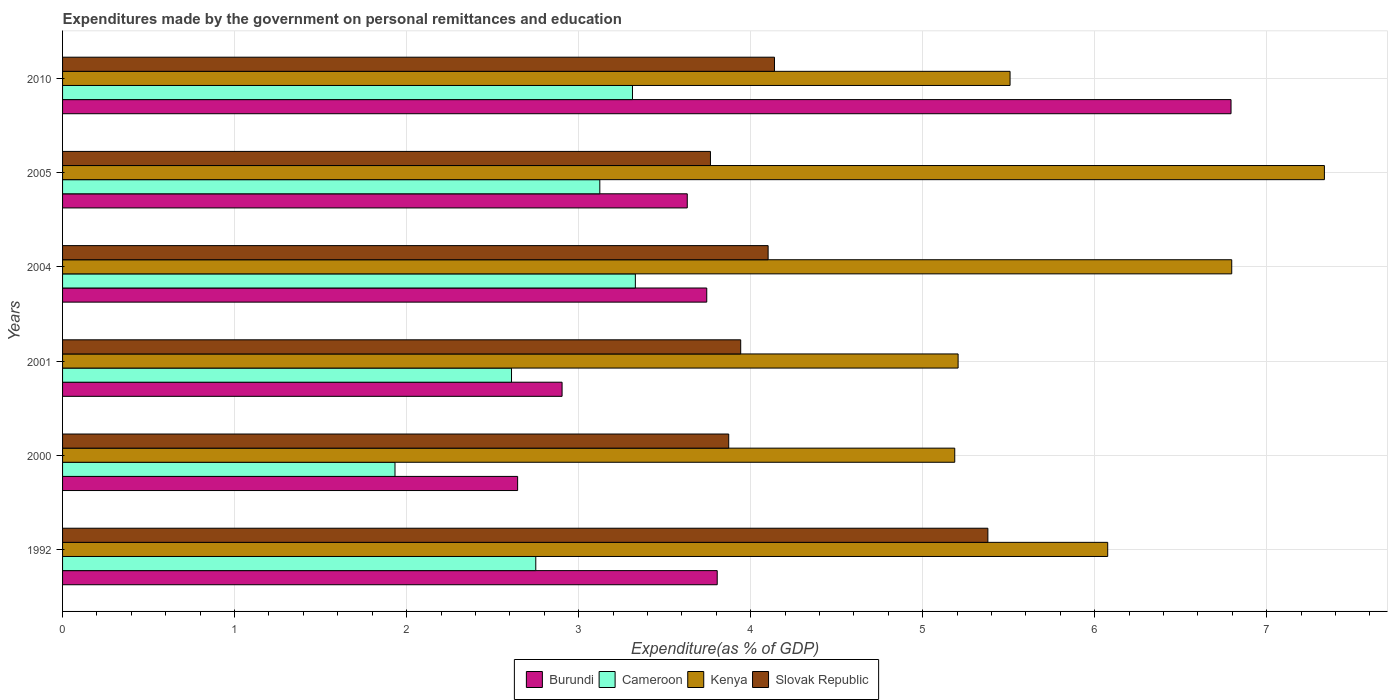Are the number of bars on each tick of the Y-axis equal?
Your answer should be very brief. Yes. How many bars are there on the 1st tick from the top?
Provide a short and direct response. 4. In how many cases, is the number of bars for a given year not equal to the number of legend labels?
Ensure brevity in your answer.  0. What is the expenditures made by the government on personal remittances and education in Cameroon in 2000?
Your answer should be compact. 1.93. Across all years, what is the maximum expenditures made by the government on personal remittances and education in Kenya?
Ensure brevity in your answer.  7.34. Across all years, what is the minimum expenditures made by the government on personal remittances and education in Slovak Republic?
Make the answer very short. 3.77. In which year was the expenditures made by the government on personal remittances and education in Kenya maximum?
Provide a succinct answer. 2005. In which year was the expenditures made by the government on personal remittances and education in Burundi minimum?
Ensure brevity in your answer.  2000. What is the total expenditures made by the government on personal remittances and education in Kenya in the graph?
Keep it short and to the point. 36.11. What is the difference between the expenditures made by the government on personal remittances and education in Cameroon in 2001 and that in 2005?
Provide a short and direct response. -0.51. What is the difference between the expenditures made by the government on personal remittances and education in Kenya in 1992 and the expenditures made by the government on personal remittances and education in Slovak Republic in 2001?
Make the answer very short. 2.13. What is the average expenditures made by the government on personal remittances and education in Slovak Republic per year?
Give a very brief answer. 4.2. In the year 2005, what is the difference between the expenditures made by the government on personal remittances and education in Burundi and expenditures made by the government on personal remittances and education in Cameroon?
Your response must be concise. 0.51. What is the ratio of the expenditures made by the government on personal remittances and education in Burundi in 2004 to that in 2010?
Provide a short and direct response. 0.55. What is the difference between the highest and the second highest expenditures made by the government on personal remittances and education in Kenya?
Keep it short and to the point. 0.54. What is the difference between the highest and the lowest expenditures made by the government on personal remittances and education in Kenya?
Offer a terse response. 2.15. In how many years, is the expenditures made by the government on personal remittances and education in Cameroon greater than the average expenditures made by the government on personal remittances and education in Cameroon taken over all years?
Keep it short and to the point. 3. What does the 2nd bar from the top in 2004 represents?
Give a very brief answer. Kenya. What does the 3rd bar from the bottom in 2001 represents?
Provide a succinct answer. Kenya. How many bars are there?
Your answer should be compact. 24. What is the difference between two consecutive major ticks on the X-axis?
Give a very brief answer. 1. Where does the legend appear in the graph?
Your response must be concise. Bottom center. How many legend labels are there?
Make the answer very short. 4. What is the title of the graph?
Keep it short and to the point. Expenditures made by the government on personal remittances and education. What is the label or title of the X-axis?
Provide a succinct answer. Expenditure(as % of GDP). What is the label or title of the Y-axis?
Keep it short and to the point. Years. What is the Expenditure(as % of GDP) of Burundi in 1992?
Keep it short and to the point. 3.81. What is the Expenditure(as % of GDP) in Cameroon in 1992?
Offer a very short reply. 2.75. What is the Expenditure(as % of GDP) of Kenya in 1992?
Your answer should be compact. 6.08. What is the Expenditure(as % of GDP) in Slovak Republic in 1992?
Your answer should be very brief. 5.38. What is the Expenditure(as % of GDP) in Burundi in 2000?
Provide a short and direct response. 2.65. What is the Expenditure(as % of GDP) in Cameroon in 2000?
Offer a very short reply. 1.93. What is the Expenditure(as % of GDP) in Kenya in 2000?
Your answer should be very brief. 5.19. What is the Expenditure(as % of GDP) of Slovak Republic in 2000?
Keep it short and to the point. 3.87. What is the Expenditure(as % of GDP) in Burundi in 2001?
Keep it short and to the point. 2.9. What is the Expenditure(as % of GDP) in Cameroon in 2001?
Your answer should be compact. 2.61. What is the Expenditure(as % of GDP) of Kenya in 2001?
Offer a terse response. 5.21. What is the Expenditure(as % of GDP) in Slovak Republic in 2001?
Provide a short and direct response. 3.94. What is the Expenditure(as % of GDP) of Burundi in 2004?
Your answer should be very brief. 3.74. What is the Expenditure(as % of GDP) of Cameroon in 2004?
Provide a succinct answer. 3.33. What is the Expenditure(as % of GDP) of Kenya in 2004?
Make the answer very short. 6.8. What is the Expenditure(as % of GDP) of Slovak Republic in 2004?
Ensure brevity in your answer.  4.1. What is the Expenditure(as % of GDP) in Burundi in 2005?
Make the answer very short. 3.63. What is the Expenditure(as % of GDP) of Cameroon in 2005?
Your answer should be very brief. 3.12. What is the Expenditure(as % of GDP) of Kenya in 2005?
Provide a succinct answer. 7.34. What is the Expenditure(as % of GDP) of Slovak Republic in 2005?
Provide a short and direct response. 3.77. What is the Expenditure(as % of GDP) in Burundi in 2010?
Keep it short and to the point. 6.79. What is the Expenditure(as % of GDP) of Cameroon in 2010?
Offer a terse response. 3.31. What is the Expenditure(as % of GDP) in Kenya in 2010?
Offer a terse response. 5.51. What is the Expenditure(as % of GDP) of Slovak Republic in 2010?
Provide a short and direct response. 4.14. Across all years, what is the maximum Expenditure(as % of GDP) of Burundi?
Provide a short and direct response. 6.79. Across all years, what is the maximum Expenditure(as % of GDP) in Cameroon?
Provide a succinct answer. 3.33. Across all years, what is the maximum Expenditure(as % of GDP) of Kenya?
Ensure brevity in your answer.  7.34. Across all years, what is the maximum Expenditure(as % of GDP) in Slovak Republic?
Offer a terse response. 5.38. Across all years, what is the minimum Expenditure(as % of GDP) of Burundi?
Your response must be concise. 2.65. Across all years, what is the minimum Expenditure(as % of GDP) in Cameroon?
Provide a short and direct response. 1.93. Across all years, what is the minimum Expenditure(as % of GDP) in Kenya?
Make the answer very short. 5.19. Across all years, what is the minimum Expenditure(as % of GDP) of Slovak Republic?
Offer a very short reply. 3.77. What is the total Expenditure(as % of GDP) in Burundi in the graph?
Make the answer very short. 23.52. What is the total Expenditure(as % of GDP) in Cameroon in the graph?
Offer a terse response. 17.06. What is the total Expenditure(as % of GDP) in Kenya in the graph?
Your answer should be compact. 36.11. What is the total Expenditure(as % of GDP) in Slovak Republic in the graph?
Offer a very short reply. 25.2. What is the difference between the Expenditure(as % of GDP) in Burundi in 1992 and that in 2000?
Offer a terse response. 1.16. What is the difference between the Expenditure(as % of GDP) in Cameroon in 1992 and that in 2000?
Your response must be concise. 0.82. What is the difference between the Expenditure(as % of GDP) of Kenya in 1992 and that in 2000?
Keep it short and to the point. 0.89. What is the difference between the Expenditure(as % of GDP) of Slovak Republic in 1992 and that in 2000?
Provide a short and direct response. 1.51. What is the difference between the Expenditure(as % of GDP) in Burundi in 1992 and that in 2001?
Ensure brevity in your answer.  0.9. What is the difference between the Expenditure(as % of GDP) in Cameroon in 1992 and that in 2001?
Make the answer very short. 0.14. What is the difference between the Expenditure(as % of GDP) of Kenya in 1992 and that in 2001?
Your response must be concise. 0.87. What is the difference between the Expenditure(as % of GDP) of Slovak Republic in 1992 and that in 2001?
Keep it short and to the point. 1.44. What is the difference between the Expenditure(as % of GDP) in Burundi in 1992 and that in 2004?
Keep it short and to the point. 0.06. What is the difference between the Expenditure(as % of GDP) in Cameroon in 1992 and that in 2004?
Your answer should be compact. -0.58. What is the difference between the Expenditure(as % of GDP) of Kenya in 1992 and that in 2004?
Ensure brevity in your answer.  -0.72. What is the difference between the Expenditure(as % of GDP) of Slovak Republic in 1992 and that in 2004?
Ensure brevity in your answer.  1.28. What is the difference between the Expenditure(as % of GDP) of Burundi in 1992 and that in 2005?
Give a very brief answer. 0.17. What is the difference between the Expenditure(as % of GDP) in Cameroon in 1992 and that in 2005?
Your answer should be very brief. -0.37. What is the difference between the Expenditure(as % of GDP) of Kenya in 1992 and that in 2005?
Offer a very short reply. -1.26. What is the difference between the Expenditure(as % of GDP) of Slovak Republic in 1992 and that in 2005?
Your response must be concise. 1.61. What is the difference between the Expenditure(as % of GDP) of Burundi in 1992 and that in 2010?
Your response must be concise. -2.99. What is the difference between the Expenditure(as % of GDP) in Cameroon in 1992 and that in 2010?
Provide a short and direct response. -0.56. What is the difference between the Expenditure(as % of GDP) of Kenya in 1992 and that in 2010?
Your answer should be compact. 0.57. What is the difference between the Expenditure(as % of GDP) in Slovak Republic in 1992 and that in 2010?
Your answer should be very brief. 1.24. What is the difference between the Expenditure(as % of GDP) in Burundi in 2000 and that in 2001?
Your response must be concise. -0.26. What is the difference between the Expenditure(as % of GDP) in Cameroon in 2000 and that in 2001?
Offer a very short reply. -0.68. What is the difference between the Expenditure(as % of GDP) in Kenya in 2000 and that in 2001?
Give a very brief answer. -0.02. What is the difference between the Expenditure(as % of GDP) of Slovak Republic in 2000 and that in 2001?
Make the answer very short. -0.07. What is the difference between the Expenditure(as % of GDP) of Burundi in 2000 and that in 2004?
Provide a short and direct response. -1.1. What is the difference between the Expenditure(as % of GDP) in Cameroon in 2000 and that in 2004?
Ensure brevity in your answer.  -1.4. What is the difference between the Expenditure(as % of GDP) of Kenya in 2000 and that in 2004?
Make the answer very short. -1.61. What is the difference between the Expenditure(as % of GDP) of Slovak Republic in 2000 and that in 2004?
Your answer should be very brief. -0.23. What is the difference between the Expenditure(as % of GDP) of Burundi in 2000 and that in 2005?
Provide a succinct answer. -0.99. What is the difference between the Expenditure(as % of GDP) in Cameroon in 2000 and that in 2005?
Your answer should be compact. -1.19. What is the difference between the Expenditure(as % of GDP) in Kenya in 2000 and that in 2005?
Keep it short and to the point. -2.15. What is the difference between the Expenditure(as % of GDP) of Slovak Republic in 2000 and that in 2005?
Your response must be concise. 0.11. What is the difference between the Expenditure(as % of GDP) in Burundi in 2000 and that in 2010?
Keep it short and to the point. -4.15. What is the difference between the Expenditure(as % of GDP) in Cameroon in 2000 and that in 2010?
Provide a short and direct response. -1.38. What is the difference between the Expenditure(as % of GDP) in Kenya in 2000 and that in 2010?
Give a very brief answer. -0.32. What is the difference between the Expenditure(as % of GDP) in Slovak Republic in 2000 and that in 2010?
Provide a short and direct response. -0.27. What is the difference between the Expenditure(as % of GDP) of Burundi in 2001 and that in 2004?
Provide a succinct answer. -0.84. What is the difference between the Expenditure(as % of GDP) of Cameroon in 2001 and that in 2004?
Ensure brevity in your answer.  -0.72. What is the difference between the Expenditure(as % of GDP) in Kenya in 2001 and that in 2004?
Offer a terse response. -1.59. What is the difference between the Expenditure(as % of GDP) in Slovak Republic in 2001 and that in 2004?
Give a very brief answer. -0.16. What is the difference between the Expenditure(as % of GDP) in Burundi in 2001 and that in 2005?
Give a very brief answer. -0.73. What is the difference between the Expenditure(as % of GDP) in Cameroon in 2001 and that in 2005?
Offer a terse response. -0.51. What is the difference between the Expenditure(as % of GDP) in Kenya in 2001 and that in 2005?
Ensure brevity in your answer.  -2.13. What is the difference between the Expenditure(as % of GDP) of Slovak Republic in 2001 and that in 2005?
Your answer should be very brief. 0.18. What is the difference between the Expenditure(as % of GDP) in Burundi in 2001 and that in 2010?
Offer a terse response. -3.89. What is the difference between the Expenditure(as % of GDP) of Cameroon in 2001 and that in 2010?
Offer a very short reply. -0.7. What is the difference between the Expenditure(as % of GDP) of Kenya in 2001 and that in 2010?
Offer a terse response. -0.3. What is the difference between the Expenditure(as % of GDP) of Slovak Republic in 2001 and that in 2010?
Your answer should be very brief. -0.2. What is the difference between the Expenditure(as % of GDP) of Burundi in 2004 and that in 2005?
Offer a terse response. 0.11. What is the difference between the Expenditure(as % of GDP) in Cameroon in 2004 and that in 2005?
Your answer should be very brief. 0.21. What is the difference between the Expenditure(as % of GDP) in Kenya in 2004 and that in 2005?
Your response must be concise. -0.54. What is the difference between the Expenditure(as % of GDP) of Slovak Republic in 2004 and that in 2005?
Ensure brevity in your answer.  0.34. What is the difference between the Expenditure(as % of GDP) of Burundi in 2004 and that in 2010?
Make the answer very short. -3.05. What is the difference between the Expenditure(as % of GDP) in Cameroon in 2004 and that in 2010?
Ensure brevity in your answer.  0.02. What is the difference between the Expenditure(as % of GDP) of Kenya in 2004 and that in 2010?
Provide a short and direct response. 1.29. What is the difference between the Expenditure(as % of GDP) in Slovak Republic in 2004 and that in 2010?
Your answer should be very brief. -0.04. What is the difference between the Expenditure(as % of GDP) of Burundi in 2005 and that in 2010?
Provide a short and direct response. -3.16. What is the difference between the Expenditure(as % of GDP) of Cameroon in 2005 and that in 2010?
Your response must be concise. -0.19. What is the difference between the Expenditure(as % of GDP) in Kenya in 2005 and that in 2010?
Ensure brevity in your answer.  1.83. What is the difference between the Expenditure(as % of GDP) of Slovak Republic in 2005 and that in 2010?
Your response must be concise. -0.37. What is the difference between the Expenditure(as % of GDP) in Burundi in 1992 and the Expenditure(as % of GDP) in Cameroon in 2000?
Provide a succinct answer. 1.87. What is the difference between the Expenditure(as % of GDP) of Burundi in 1992 and the Expenditure(as % of GDP) of Kenya in 2000?
Provide a short and direct response. -1.38. What is the difference between the Expenditure(as % of GDP) in Burundi in 1992 and the Expenditure(as % of GDP) in Slovak Republic in 2000?
Keep it short and to the point. -0.07. What is the difference between the Expenditure(as % of GDP) in Cameroon in 1992 and the Expenditure(as % of GDP) in Kenya in 2000?
Give a very brief answer. -2.44. What is the difference between the Expenditure(as % of GDP) of Cameroon in 1992 and the Expenditure(as % of GDP) of Slovak Republic in 2000?
Make the answer very short. -1.12. What is the difference between the Expenditure(as % of GDP) in Kenya in 1992 and the Expenditure(as % of GDP) in Slovak Republic in 2000?
Your response must be concise. 2.2. What is the difference between the Expenditure(as % of GDP) of Burundi in 1992 and the Expenditure(as % of GDP) of Cameroon in 2001?
Provide a succinct answer. 1.2. What is the difference between the Expenditure(as % of GDP) in Burundi in 1992 and the Expenditure(as % of GDP) in Kenya in 2001?
Your response must be concise. -1.4. What is the difference between the Expenditure(as % of GDP) of Burundi in 1992 and the Expenditure(as % of GDP) of Slovak Republic in 2001?
Your answer should be very brief. -0.14. What is the difference between the Expenditure(as % of GDP) of Cameroon in 1992 and the Expenditure(as % of GDP) of Kenya in 2001?
Provide a short and direct response. -2.46. What is the difference between the Expenditure(as % of GDP) of Cameroon in 1992 and the Expenditure(as % of GDP) of Slovak Republic in 2001?
Offer a terse response. -1.19. What is the difference between the Expenditure(as % of GDP) in Kenya in 1992 and the Expenditure(as % of GDP) in Slovak Republic in 2001?
Give a very brief answer. 2.13. What is the difference between the Expenditure(as % of GDP) of Burundi in 1992 and the Expenditure(as % of GDP) of Cameroon in 2004?
Keep it short and to the point. 0.48. What is the difference between the Expenditure(as % of GDP) in Burundi in 1992 and the Expenditure(as % of GDP) in Kenya in 2004?
Give a very brief answer. -2.99. What is the difference between the Expenditure(as % of GDP) of Burundi in 1992 and the Expenditure(as % of GDP) of Slovak Republic in 2004?
Keep it short and to the point. -0.3. What is the difference between the Expenditure(as % of GDP) of Cameroon in 1992 and the Expenditure(as % of GDP) of Kenya in 2004?
Your response must be concise. -4.05. What is the difference between the Expenditure(as % of GDP) of Cameroon in 1992 and the Expenditure(as % of GDP) of Slovak Republic in 2004?
Your answer should be very brief. -1.35. What is the difference between the Expenditure(as % of GDP) of Kenya in 1992 and the Expenditure(as % of GDP) of Slovak Republic in 2004?
Make the answer very short. 1.97. What is the difference between the Expenditure(as % of GDP) of Burundi in 1992 and the Expenditure(as % of GDP) of Cameroon in 2005?
Provide a succinct answer. 0.68. What is the difference between the Expenditure(as % of GDP) of Burundi in 1992 and the Expenditure(as % of GDP) of Kenya in 2005?
Keep it short and to the point. -3.53. What is the difference between the Expenditure(as % of GDP) in Burundi in 1992 and the Expenditure(as % of GDP) in Slovak Republic in 2005?
Your answer should be very brief. 0.04. What is the difference between the Expenditure(as % of GDP) in Cameroon in 1992 and the Expenditure(as % of GDP) in Kenya in 2005?
Make the answer very short. -4.58. What is the difference between the Expenditure(as % of GDP) in Cameroon in 1992 and the Expenditure(as % of GDP) in Slovak Republic in 2005?
Your answer should be very brief. -1.02. What is the difference between the Expenditure(as % of GDP) of Kenya in 1992 and the Expenditure(as % of GDP) of Slovak Republic in 2005?
Your response must be concise. 2.31. What is the difference between the Expenditure(as % of GDP) of Burundi in 1992 and the Expenditure(as % of GDP) of Cameroon in 2010?
Your response must be concise. 0.49. What is the difference between the Expenditure(as % of GDP) in Burundi in 1992 and the Expenditure(as % of GDP) in Kenya in 2010?
Ensure brevity in your answer.  -1.7. What is the difference between the Expenditure(as % of GDP) of Burundi in 1992 and the Expenditure(as % of GDP) of Slovak Republic in 2010?
Your answer should be compact. -0.33. What is the difference between the Expenditure(as % of GDP) of Cameroon in 1992 and the Expenditure(as % of GDP) of Kenya in 2010?
Provide a short and direct response. -2.76. What is the difference between the Expenditure(as % of GDP) of Cameroon in 1992 and the Expenditure(as % of GDP) of Slovak Republic in 2010?
Ensure brevity in your answer.  -1.39. What is the difference between the Expenditure(as % of GDP) of Kenya in 1992 and the Expenditure(as % of GDP) of Slovak Republic in 2010?
Your response must be concise. 1.94. What is the difference between the Expenditure(as % of GDP) of Burundi in 2000 and the Expenditure(as % of GDP) of Cameroon in 2001?
Offer a terse response. 0.04. What is the difference between the Expenditure(as % of GDP) in Burundi in 2000 and the Expenditure(as % of GDP) in Kenya in 2001?
Offer a very short reply. -2.56. What is the difference between the Expenditure(as % of GDP) of Burundi in 2000 and the Expenditure(as % of GDP) of Slovak Republic in 2001?
Provide a succinct answer. -1.3. What is the difference between the Expenditure(as % of GDP) in Cameroon in 2000 and the Expenditure(as % of GDP) in Kenya in 2001?
Provide a succinct answer. -3.27. What is the difference between the Expenditure(as % of GDP) in Cameroon in 2000 and the Expenditure(as % of GDP) in Slovak Republic in 2001?
Your response must be concise. -2.01. What is the difference between the Expenditure(as % of GDP) of Kenya in 2000 and the Expenditure(as % of GDP) of Slovak Republic in 2001?
Ensure brevity in your answer.  1.24. What is the difference between the Expenditure(as % of GDP) in Burundi in 2000 and the Expenditure(as % of GDP) in Cameroon in 2004?
Your response must be concise. -0.68. What is the difference between the Expenditure(as % of GDP) of Burundi in 2000 and the Expenditure(as % of GDP) of Kenya in 2004?
Make the answer very short. -4.15. What is the difference between the Expenditure(as % of GDP) of Burundi in 2000 and the Expenditure(as % of GDP) of Slovak Republic in 2004?
Make the answer very short. -1.46. What is the difference between the Expenditure(as % of GDP) of Cameroon in 2000 and the Expenditure(as % of GDP) of Kenya in 2004?
Keep it short and to the point. -4.86. What is the difference between the Expenditure(as % of GDP) of Cameroon in 2000 and the Expenditure(as % of GDP) of Slovak Republic in 2004?
Keep it short and to the point. -2.17. What is the difference between the Expenditure(as % of GDP) in Kenya in 2000 and the Expenditure(as % of GDP) in Slovak Republic in 2004?
Give a very brief answer. 1.08. What is the difference between the Expenditure(as % of GDP) of Burundi in 2000 and the Expenditure(as % of GDP) of Cameroon in 2005?
Your response must be concise. -0.48. What is the difference between the Expenditure(as % of GDP) in Burundi in 2000 and the Expenditure(as % of GDP) in Kenya in 2005?
Keep it short and to the point. -4.69. What is the difference between the Expenditure(as % of GDP) in Burundi in 2000 and the Expenditure(as % of GDP) in Slovak Republic in 2005?
Offer a terse response. -1.12. What is the difference between the Expenditure(as % of GDP) of Cameroon in 2000 and the Expenditure(as % of GDP) of Kenya in 2005?
Your answer should be very brief. -5.4. What is the difference between the Expenditure(as % of GDP) of Cameroon in 2000 and the Expenditure(as % of GDP) of Slovak Republic in 2005?
Ensure brevity in your answer.  -1.83. What is the difference between the Expenditure(as % of GDP) of Kenya in 2000 and the Expenditure(as % of GDP) of Slovak Republic in 2005?
Provide a short and direct response. 1.42. What is the difference between the Expenditure(as % of GDP) in Burundi in 2000 and the Expenditure(as % of GDP) in Cameroon in 2010?
Keep it short and to the point. -0.67. What is the difference between the Expenditure(as % of GDP) of Burundi in 2000 and the Expenditure(as % of GDP) of Kenya in 2010?
Your answer should be compact. -2.86. What is the difference between the Expenditure(as % of GDP) of Burundi in 2000 and the Expenditure(as % of GDP) of Slovak Republic in 2010?
Provide a succinct answer. -1.49. What is the difference between the Expenditure(as % of GDP) in Cameroon in 2000 and the Expenditure(as % of GDP) in Kenya in 2010?
Offer a very short reply. -3.58. What is the difference between the Expenditure(as % of GDP) of Cameroon in 2000 and the Expenditure(as % of GDP) of Slovak Republic in 2010?
Ensure brevity in your answer.  -2.21. What is the difference between the Expenditure(as % of GDP) in Kenya in 2000 and the Expenditure(as % of GDP) in Slovak Republic in 2010?
Provide a short and direct response. 1.05. What is the difference between the Expenditure(as % of GDP) in Burundi in 2001 and the Expenditure(as % of GDP) in Cameroon in 2004?
Offer a very short reply. -0.43. What is the difference between the Expenditure(as % of GDP) in Burundi in 2001 and the Expenditure(as % of GDP) in Kenya in 2004?
Ensure brevity in your answer.  -3.89. What is the difference between the Expenditure(as % of GDP) of Burundi in 2001 and the Expenditure(as % of GDP) of Slovak Republic in 2004?
Offer a terse response. -1.2. What is the difference between the Expenditure(as % of GDP) of Cameroon in 2001 and the Expenditure(as % of GDP) of Kenya in 2004?
Keep it short and to the point. -4.19. What is the difference between the Expenditure(as % of GDP) in Cameroon in 2001 and the Expenditure(as % of GDP) in Slovak Republic in 2004?
Keep it short and to the point. -1.49. What is the difference between the Expenditure(as % of GDP) in Kenya in 2001 and the Expenditure(as % of GDP) in Slovak Republic in 2004?
Provide a succinct answer. 1.1. What is the difference between the Expenditure(as % of GDP) of Burundi in 2001 and the Expenditure(as % of GDP) of Cameroon in 2005?
Your answer should be very brief. -0.22. What is the difference between the Expenditure(as % of GDP) in Burundi in 2001 and the Expenditure(as % of GDP) in Kenya in 2005?
Your answer should be very brief. -4.43. What is the difference between the Expenditure(as % of GDP) of Burundi in 2001 and the Expenditure(as % of GDP) of Slovak Republic in 2005?
Give a very brief answer. -0.86. What is the difference between the Expenditure(as % of GDP) of Cameroon in 2001 and the Expenditure(as % of GDP) of Kenya in 2005?
Make the answer very short. -4.73. What is the difference between the Expenditure(as % of GDP) of Cameroon in 2001 and the Expenditure(as % of GDP) of Slovak Republic in 2005?
Keep it short and to the point. -1.16. What is the difference between the Expenditure(as % of GDP) of Kenya in 2001 and the Expenditure(as % of GDP) of Slovak Republic in 2005?
Make the answer very short. 1.44. What is the difference between the Expenditure(as % of GDP) in Burundi in 2001 and the Expenditure(as % of GDP) in Cameroon in 2010?
Offer a very short reply. -0.41. What is the difference between the Expenditure(as % of GDP) in Burundi in 2001 and the Expenditure(as % of GDP) in Kenya in 2010?
Your answer should be compact. -2.6. What is the difference between the Expenditure(as % of GDP) of Burundi in 2001 and the Expenditure(as % of GDP) of Slovak Republic in 2010?
Provide a short and direct response. -1.23. What is the difference between the Expenditure(as % of GDP) in Cameroon in 2001 and the Expenditure(as % of GDP) in Kenya in 2010?
Make the answer very short. -2.9. What is the difference between the Expenditure(as % of GDP) of Cameroon in 2001 and the Expenditure(as % of GDP) of Slovak Republic in 2010?
Make the answer very short. -1.53. What is the difference between the Expenditure(as % of GDP) of Kenya in 2001 and the Expenditure(as % of GDP) of Slovak Republic in 2010?
Provide a short and direct response. 1.07. What is the difference between the Expenditure(as % of GDP) in Burundi in 2004 and the Expenditure(as % of GDP) in Cameroon in 2005?
Provide a succinct answer. 0.62. What is the difference between the Expenditure(as % of GDP) of Burundi in 2004 and the Expenditure(as % of GDP) of Kenya in 2005?
Give a very brief answer. -3.59. What is the difference between the Expenditure(as % of GDP) of Burundi in 2004 and the Expenditure(as % of GDP) of Slovak Republic in 2005?
Ensure brevity in your answer.  -0.02. What is the difference between the Expenditure(as % of GDP) of Cameroon in 2004 and the Expenditure(as % of GDP) of Kenya in 2005?
Keep it short and to the point. -4.01. What is the difference between the Expenditure(as % of GDP) in Cameroon in 2004 and the Expenditure(as % of GDP) in Slovak Republic in 2005?
Offer a terse response. -0.44. What is the difference between the Expenditure(as % of GDP) of Kenya in 2004 and the Expenditure(as % of GDP) of Slovak Republic in 2005?
Provide a short and direct response. 3.03. What is the difference between the Expenditure(as % of GDP) in Burundi in 2004 and the Expenditure(as % of GDP) in Cameroon in 2010?
Your response must be concise. 0.43. What is the difference between the Expenditure(as % of GDP) of Burundi in 2004 and the Expenditure(as % of GDP) of Kenya in 2010?
Keep it short and to the point. -1.76. What is the difference between the Expenditure(as % of GDP) of Burundi in 2004 and the Expenditure(as % of GDP) of Slovak Republic in 2010?
Your response must be concise. -0.39. What is the difference between the Expenditure(as % of GDP) of Cameroon in 2004 and the Expenditure(as % of GDP) of Kenya in 2010?
Offer a terse response. -2.18. What is the difference between the Expenditure(as % of GDP) in Cameroon in 2004 and the Expenditure(as % of GDP) in Slovak Republic in 2010?
Keep it short and to the point. -0.81. What is the difference between the Expenditure(as % of GDP) in Kenya in 2004 and the Expenditure(as % of GDP) in Slovak Republic in 2010?
Make the answer very short. 2.66. What is the difference between the Expenditure(as % of GDP) in Burundi in 2005 and the Expenditure(as % of GDP) in Cameroon in 2010?
Offer a terse response. 0.32. What is the difference between the Expenditure(as % of GDP) in Burundi in 2005 and the Expenditure(as % of GDP) in Kenya in 2010?
Offer a terse response. -1.88. What is the difference between the Expenditure(as % of GDP) of Burundi in 2005 and the Expenditure(as % of GDP) of Slovak Republic in 2010?
Keep it short and to the point. -0.51. What is the difference between the Expenditure(as % of GDP) of Cameroon in 2005 and the Expenditure(as % of GDP) of Kenya in 2010?
Your response must be concise. -2.38. What is the difference between the Expenditure(as % of GDP) of Cameroon in 2005 and the Expenditure(as % of GDP) of Slovak Republic in 2010?
Offer a terse response. -1.02. What is the difference between the Expenditure(as % of GDP) of Kenya in 2005 and the Expenditure(as % of GDP) of Slovak Republic in 2010?
Give a very brief answer. 3.2. What is the average Expenditure(as % of GDP) in Burundi per year?
Offer a very short reply. 3.92. What is the average Expenditure(as % of GDP) in Cameroon per year?
Provide a short and direct response. 2.84. What is the average Expenditure(as % of GDP) of Kenya per year?
Offer a terse response. 6.02. What is the average Expenditure(as % of GDP) in Slovak Republic per year?
Ensure brevity in your answer.  4.2. In the year 1992, what is the difference between the Expenditure(as % of GDP) of Burundi and Expenditure(as % of GDP) of Cameroon?
Ensure brevity in your answer.  1.05. In the year 1992, what is the difference between the Expenditure(as % of GDP) of Burundi and Expenditure(as % of GDP) of Kenya?
Keep it short and to the point. -2.27. In the year 1992, what is the difference between the Expenditure(as % of GDP) of Burundi and Expenditure(as % of GDP) of Slovak Republic?
Keep it short and to the point. -1.57. In the year 1992, what is the difference between the Expenditure(as % of GDP) in Cameroon and Expenditure(as % of GDP) in Kenya?
Make the answer very short. -3.32. In the year 1992, what is the difference between the Expenditure(as % of GDP) of Cameroon and Expenditure(as % of GDP) of Slovak Republic?
Make the answer very short. -2.63. In the year 1992, what is the difference between the Expenditure(as % of GDP) in Kenya and Expenditure(as % of GDP) in Slovak Republic?
Provide a short and direct response. 0.7. In the year 2000, what is the difference between the Expenditure(as % of GDP) in Burundi and Expenditure(as % of GDP) in Cameroon?
Ensure brevity in your answer.  0.71. In the year 2000, what is the difference between the Expenditure(as % of GDP) in Burundi and Expenditure(as % of GDP) in Kenya?
Your answer should be compact. -2.54. In the year 2000, what is the difference between the Expenditure(as % of GDP) in Burundi and Expenditure(as % of GDP) in Slovak Republic?
Your answer should be very brief. -1.23. In the year 2000, what is the difference between the Expenditure(as % of GDP) in Cameroon and Expenditure(as % of GDP) in Kenya?
Ensure brevity in your answer.  -3.25. In the year 2000, what is the difference between the Expenditure(as % of GDP) in Cameroon and Expenditure(as % of GDP) in Slovak Republic?
Provide a short and direct response. -1.94. In the year 2000, what is the difference between the Expenditure(as % of GDP) of Kenya and Expenditure(as % of GDP) of Slovak Republic?
Ensure brevity in your answer.  1.31. In the year 2001, what is the difference between the Expenditure(as % of GDP) of Burundi and Expenditure(as % of GDP) of Cameroon?
Ensure brevity in your answer.  0.29. In the year 2001, what is the difference between the Expenditure(as % of GDP) of Burundi and Expenditure(as % of GDP) of Kenya?
Provide a succinct answer. -2.3. In the year 2001, what is the difference between the Expenditure(as % of GDP) in Burundi and Expenditure(as % of GDP) in Slovak Republic?
Provide a succinct answer. -1.04. In the year 2001, what is the difference between the Expenditure(as % of GDP) of Cameroon and Expenditure(as % of GDP) of Kenya?
Provide a succinct answer. -2.6. In the year 2001, what is the difference between the Expenditure(as % of GDP) of Cameroon and Expenditure(as % of GDP) of Slovak Republic?
Offer a very short reply. -1.33. In the year 2001, what is the difference between the Expenditure(as % of GDP) of Kenya and Expenditure(as % of GDP) of Slovak Republic?
Provide a succinct answer. 1.26. In the year 2004, what is the difference between the Expenditure(as % of GDP) of Burundi and Expenditure(as % of GDP) of Cameroon?
Make the answer very short. 0.42. In the year 2004, what is the difference between the Expenditure(as % of GDP) of Burundi and Expenditure(as % of GDP) of Kenya?
Your response must be concise. -3.05. In the year 2004, what is the difference between the Expenditure(as % of GDP) in Burundi and Expenditure(as % of GDP) in Slovak Republic?
Provide a short and direct response. -0.36. In the year 2004, what is the difference between the Expenditure(as % of GDP) in Cameroon and Expenditure(as % of GDP) in Kenya?
Your answer should be very brief. -3.47. In the year 2004, what is the difference between the Expenditure(as % of GDP) in Cameroon and Expenditure(as % of GDP) in Slovak Republic?
Your answer should be compact. -0.77. In the year 2004, what is the difference between the Expenditure(as % of GDP) of Kenya and Expenditure(as % of GDP) of Slovak Republic?
Provide a succinct answer. 2.7. In the year 2005, what is the difference between the Expenditure(as % of GDP) of Burundi and Expenditure(as % of GDP) of Cameroon?
Provide a succinct answer. 0.51. In the year 2005, what is the difference between the Expenditure(as % of GDP) in Burundi and Expenditure(as % of GDP) in Kenya?
Offer a very short reply. -3.7. In the year 2005, what is the difference between the Expenditure(as % of GDP) in Burundi and Expenditure(as % of GDP) in Slovak Republic?
Your response must be concise. -0.13. In the year 2005, what is the difference between the Expenditure(as % of GDP) in Cameroon and Expenditure(as % of GDP) in Kenya?
Offer a very short reply. -4.21. In the year 2005, what is the difference between the Expenditure(as % of GDP) in Cameroon and Expenditure(as % of GDP) in Slovak Republic?
Your response must be concise. -0.64. In the year 2005, what is the difference between the Expenditure(as % of GDP) in Kenya and Expenditure(as % of GDP) in Slovak Republic?
Your response must be concise. 3.57. In the year 2010, what is the difference between the Expenditure(as % of GDP) in Burundi and Expenditure(as % of GDP) in Cameroon?
Ensure brevity in your answer.  3.48. In the year 2010, what is the difference between the Expenditure(as % of GDP) in Burundi and Expenditure(as % of GDP) in Kenya?
Your answer should be compact. 1.28. In the year 2010, what is the difference between the Expenditure(as % of GDP) in Burundi and Expenditure(as % of GDP) in Slovak Republic?
Offer a very short reply. 2.65. In the year 2010, what is the difference between the Expenditure(as % of GDP) of Cameroon and Expenditure(as % of GDP) of Kenya?
Provide a short and direct response. -2.19. In the year 2010, what is the difference between the Expenditure(as % of GDP) in Cameroon and Expenditure(as % of GDP) in Slovak Republic?
Offer a very short reply. -0.83. In the year 2010, what is the difference between the Expenditure(as % of GDP) in Kenya and Expenditure(as % of GDP) in Slovak Republic?
Your answer should be compact. 1.37. What is the ratio of the Expenditure(as % of GDP) in Burundi in 1992 to that in 2000?
Offer a terse response. 1.44. What is the ratio of the Expenditure(as % of GDP) in Cameroon in 1992 to that in 2000?
Your response must be concise. 1.42. What is the ratio of the Expenditure(as % of GDP) in Kenya in 1992 to that in 2000?
Ensure brevity in your answer.  1.17. What is the ratio of the Expenditure(as % of GDP) in Slovak Republic in 1992 to that in 2000?
Your response must be concise. 1.39. What is the ratio of the Expenditure(as % of GDP) of Burundi in 1992 to that in 2001?
Your response must be concise. 1.31. What is the ratio of the Expenditure(as % of GDP) of Cameroon in 1992 to that in 2001?
Offer a terse response. 1.05. What is the ratio of the Expenditure(as % of GDP) in Kenya in 1992 to that in 2001?
Provide a succinct answer. 1.17. What is the ratio of the Expenditure(as % of GDP) of Slovak Republic in 1992 to that in 2001?
Offer a very short reply. 1.36. What is the ratio of the Expenditure(as % of GDP) of Burundi in 1992 to that in 2004?
Keep it short and to the point. 1.02. What is the ratio of the Expenditure(as % of GDP) in Cameroon in 1992 to that in 2004?
Your answer should be compact. 0.83. What is the ratio of the Expenditure(as % of GDP) in Kenya in 1992 to that in 2004?
Provide a succinct answer. 0.89. What is the ratio of the Expenditure(as % of GDP) in Slovak Republic in 1992 to that in 2004?
Your response must be concise. 1.31. What is the ratio of the Expenditure(as % of GDP) of Burundi in 1992 to that in 2005?
Your response must be concise. 1.05. What is the ratio of the Expenditure(as % of GDP) in Cameroon in 1992 to that in 2005?
Keep it short and to the point. 0.88. What is the ratio of the Expenditure(as % of GDP) in Kenya in 1992 to that in 2005?
Give a very brief answer. 0.83. What is the ratio of the Expenditure(as % of GDP) of Slovak Republic in 1992 to that in 2005?
Keep it short and to the point. 1.43. What is the ratio of the Expenditure(as % of GDP) of Burundi in 1992 to that in 2010?
Give a very brief answer. 0.56. What is the ratio of the Expenditure(as % of GDP) in Cameroon in 1992 to that in 2010?
Offer a very short reply. 0.83. What is the ratio of the Expenditure(as % of GDP) of Kenya in 1992 to that in 2010?
Your response must be concise. 1.1. What is the ratio of the Expenditure(as % of GDP) of Slovak Republic in 1992 to that in 2010?
Give a very brief answer. 1.3. What is the ratio of the Expenditure(as % of GDP) of Burundi in 2000 to that in 2001?
Your answer should be compact. 0.91. What is the ratio of the Expenditure(as % of GDP) of Cameroon in 2000 to that in 2001?
Make the answer very short. 0.74. What is the ratio of the Expenditure(as % of GDP) of Slovak Republic in 2000 to that in 2001?
Make the answer very short. 0.98. What is the ratio of the Expenditure(as % of GDP) of Burundi in 2000 to that in 2004?
Give a very brief answer. 0.71. What is the ratio of the Expenditure(as % of GDP) of Cameroon in 2000 to that in 2004?
Your response must be concise. 0.58. What is the ratio of the Expenditure(as % of GDP) in Kenya in 2000 to that in 2004?
Offer a terse response. 0.76. What is the ratio of the Expenditure(as % of GDP) of Slovak Republic in 2000 to that in 2004?
Your answer should be compact. 0.94. What is the ratio of the Expenditure(as % of GDP) of Burundi in 2000 to that in 2005?
Provide a succinct answer. 0.73. What is the ratio of the Expenditure(as % of GDP) in Cameroon in 2000 to that in 2005?
Offer a very short reply. 0.62. What is the ratio of the Expenditure(as % of GDP) in Kenya in 2000 to that in 2005?
Make the answer very short. 0.71. What is the ratio of the Expenditure(as % of GDP) of Slovak Republic in 2000 to that in 2005?
Your answer should be very brief. 1.03. What is the ratio of the Expenditure(as % of GDP) in Burundi in 2000 to that in 2010?
Your answer should be very brief. 0.39. What is the ratio of the Expenditure(as % of GDP) in Cameroon in 2000 to that in 2010?
Give a very brief answer. 0.58. What is the ratio of the Expenditure(as % of GDP) in Kenya in 2000 to that in 2010?
Offer a very short reply. 0.94. What is the ratio of the Expenditure(as % of GDP) in Slovak Republic in 2000 to that in 2010?
Your response must be concise. 0.94. What is the ratio of the Expenditure(as % of GDP) in Burundi in 2001 to that in 2004?
Give a very brief answer. 0.78. What is the ratio of the Expenditure(as % of GDP) of Cameroon in 2001 to that in 2004?
Your response must be concise. 0.78. What is the ratio of the Expenditure(as % of GDP) of Kenya in 2001 to that in 2004?
Provide a succinct answer. 0.77. What is the ratio of the Expenditure(as % of GDP) of Slovak Republic in 2001 to that in 2004?
Your answer should be very brief. 0.96. What is the ratio of the Expenditure(as % of GDP) in Burundi in 2001 to that in 2005?
Provide a short and direct response. 0.8. What is the ratio of the Expenditure(as % of GDP) in Cameroon in 2001 to that in 2005?
Offer a very short reply. 0.84. What is the ratio of the Expenditure(as % of GDP) of Kenya in 2001 to that in 2005?
Your response must be concise. 0.71. What is the ratio of the Expenditure(as % of GDP) of Slovak Republic in 2001 to that in 2005?
Provide a short and direct response. 1.05. What is the ratio of the Expenditure(as % of GDP) of Burundi in 2001 to that in 2010?
Provide a succinct answer. 0.43. What is the ratio of the Expenditure(as % of GDP) in Cameroon in 2001 to that in 2010?
Your response must be concise. 0.79. What is the ratio of the Expenditure(as % of GDP) of Kenya in 2001 to that in 2010?
Your answer should be compact. 0.95. What is the ratio of the Expenditure(as % of GDP) in Slovak Republic in 2001 to that in 2010?
Offer a terse response. 0.95. What is the ratio of the Expenditure(as % of GDP) in Burundi in 2004 to that in 2005?
Provide a short and direct response. 1.03. What is the ratio of the Expenditure(as % of GDP) in Cameroon in 2004 to that in 2005?
Your answer should be compact. 1.07. What is the ratio of the Expenditure(as % of GDP) in Kenya in 2004 to that in 2005?
Your response must be concise. 0.93. What is the ratio of the Expenditure(as % of GDP) in Slovak Republic in 2004 to that in 2005?
Keep it short and to the point. 1.09. What is the ratio of the Expenditure(as % of GDP) of Burundi in 2004 to that in 2010?
Give a very brief answer. 0.55. What is the ratio of the Expenditure(as % of GDP) of Cameroon in 2004 to that in 2010?
Provide a short and direct response. 1. What is the ratio of the Expenditure(as % of GDP) of Kenya in 2004 to that in 2010?
Offer a very short reply. 1.23. What is the ratio of the Expenditure(as % of GDP) in Burundi in 2005 to that in 2010?
Make the answer very short. 0.53. What is the ratio of the Expenditure(as % of GDP) in Cameroon in 2005 to that in 2010?
Your answer should be compact. 0.94. What is the ratio of the Expenditure(as % of GDP) of Kenya in 2005 to that in 2010?
Your answer should be very brief. 1.33. What is the ratio of the Expenditure(as % of GDP) in Slovak Republic in 2005 to that in 2010?
Your answer should be compact. 0.91. What is the difference between the highest and the second highest Expenditure(as % of GDP) of Burundi?
Your response must be concise. 2.99. What is the difference between the highest and the second highest Expenditure(as % of GDP) of Cameroon?
Make the answer very short. 0.02. What is the difference between the highest and the second highest Expenditure(as % of GDP) in Kenya?
Give a very brief answer. 0.54. What is the difference between the highest and the second highest Expenditure(as % of GDP) in Slovak Republic?
Provide a short and direct response. 1.24. What is the difference between the highest and the lowest Expenditure(as % of GDP) in Burundi?
Your response must be concise. 4.15. What is the difference between the highest and the lowest Expenditure(as % of GDP) in Cameroon?
Your answer should be compact. 1.4. What is the difference between the highest and the lowest Expenditure(as % of GDP) in Kenya?
Make the answer very short. 2.15. What is the difference between the highest and the lowest Expenditure(as % of GDP) of Slovak Republic?
Your answer should be very brief. 1.61. 